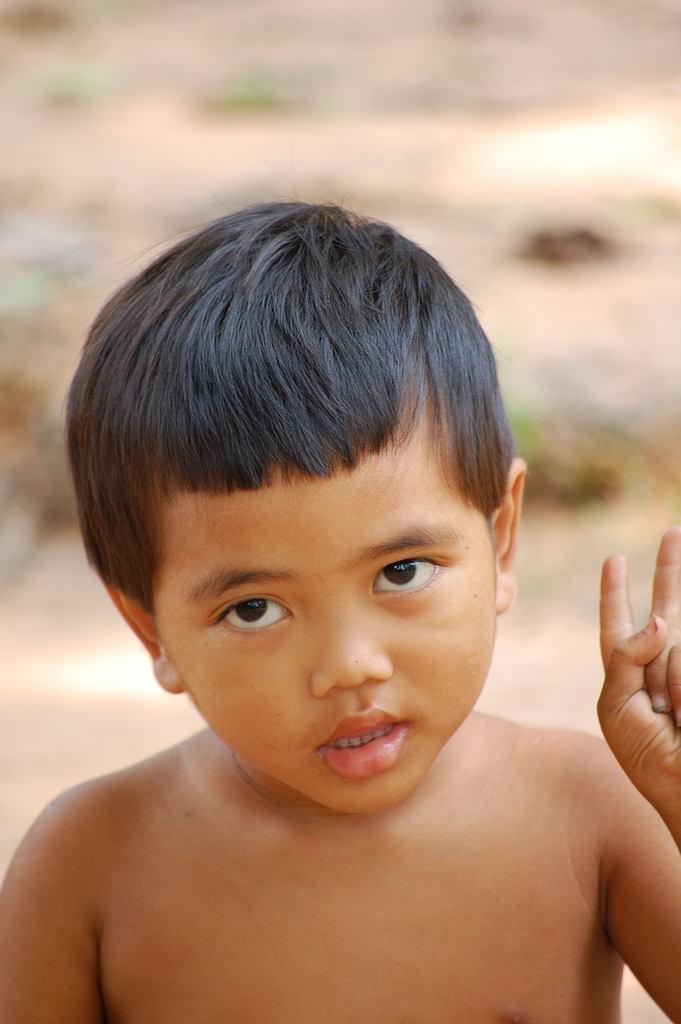How would you summarize this image in a sentence or two? This picture shows a boy and he is showing his two fingers. 